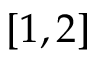<formula> <loc_0><loc_0><loc_500><loc_500>[ 1 , 2 ]</formula> 